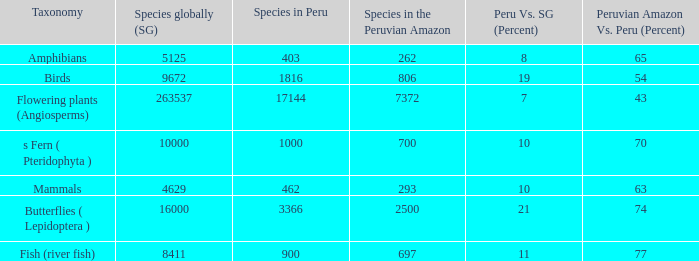Out of the 8,411 species found across the world, how many are present in the peruvian amazon? 1.0. 